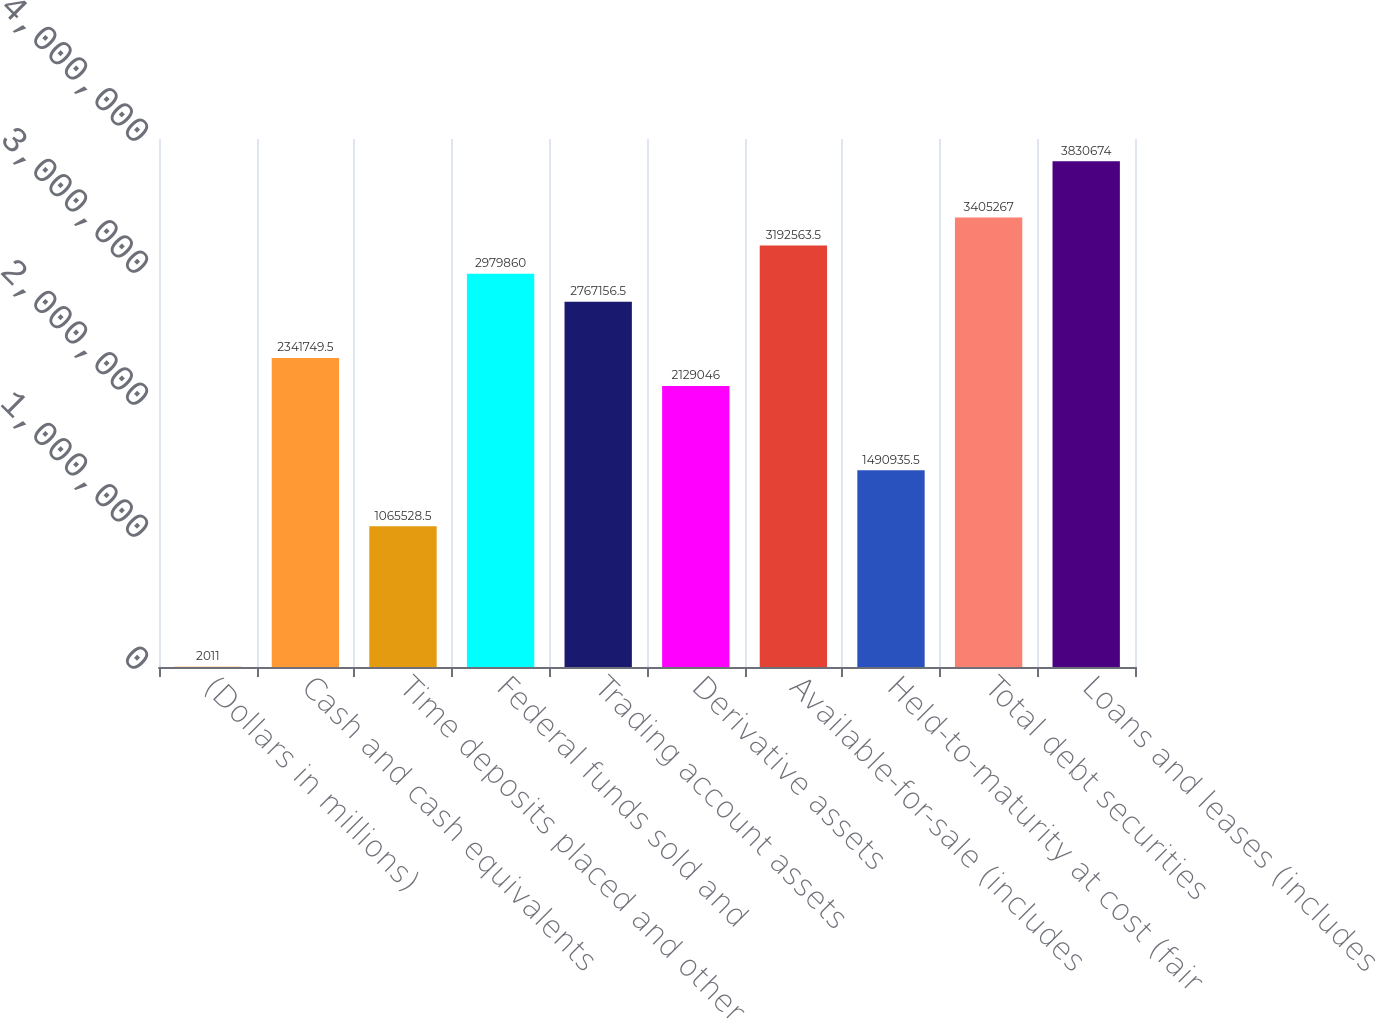Convert chart to OTSL. <chart><loc_0><loc_0><loc_500><loc_500><bar_chart><fcel>(Dollars in millions)<fcel>Cash and cash equivalents<fcel>Time deposits placed and other<fcel>Federal funds sold and<fcel>Trading account assets<fcel>Derivative assets<fcel>Available-for-sale (includes<fcel>Held-to-maturity at cost (fair<fcel>Total debt securities<fcel>Loans and leases (includes<nl><fcel>2011<fcel>2.34175e+06<fcel>1.06553e+06<fcel>2.97986e+06<fcel>2.76716e+06<fcel>2.12905e+06<fcel>3.19256e+06<fcel>1.49094e+06<fcel>3.40527e+06<fcel>3.83067e+06<nl></chart> 